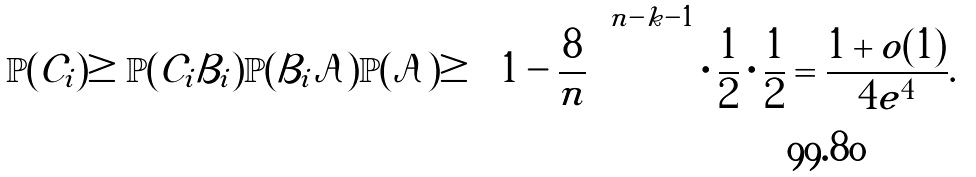<formula> <loc_0><loc_0><loc_500><loc_500>\mathbb { P } ( \mathcal { C } _ { i } ) \geq \mathbb { P } ( \mathcal { C } _ { i } | \mathcal { B } _ { i } ) \mathbb { P } ( \mathcal { B } _ { i } | \mathcal { A } ) \mathbb { P } ( \mathcal { A } ) \geq \left ( 1 - \frac { 8 } { n } \right ) ^ { n - k - 1 } \cdot \frac { 1 } { 2 } \cdot \frac { 1 } { 2 } = \frac { 1 + o ( 1 ) } { 4 e ^ { 4 } } .</formula> 